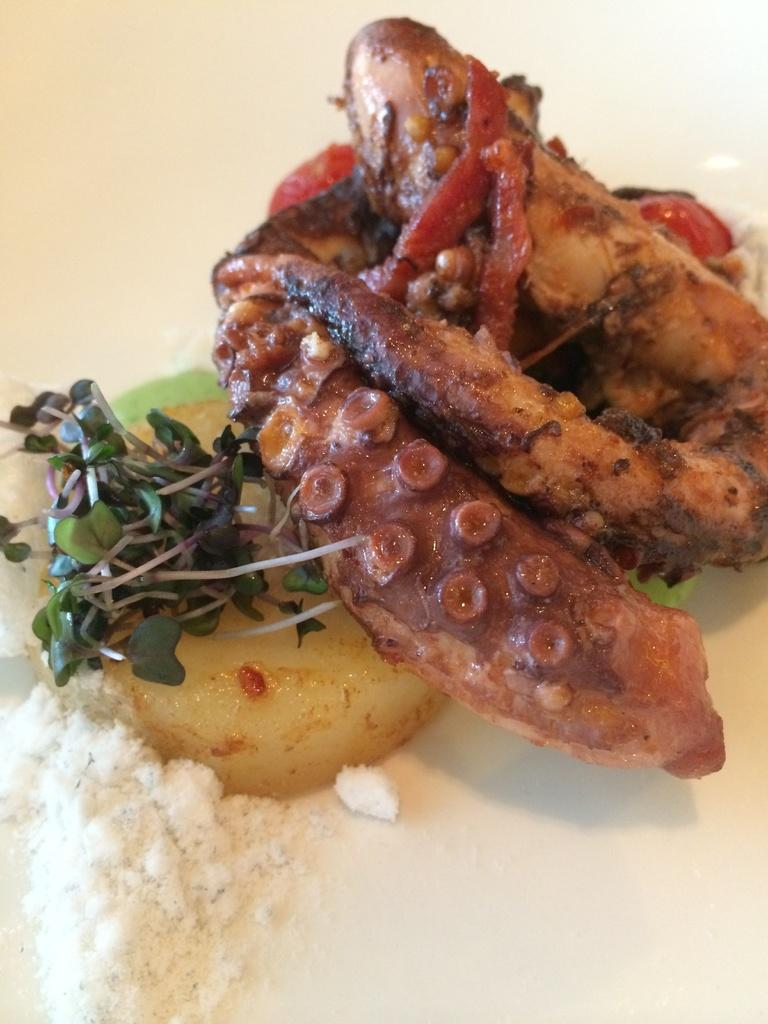What is the main subject of the image? The main subject of the image is food. Where is the food located in the image? The food is on a platform. What is the interest rate of the loan mentioned in the image? There is no mention of a loan or interest rate in the image; it only features food on a platform. 